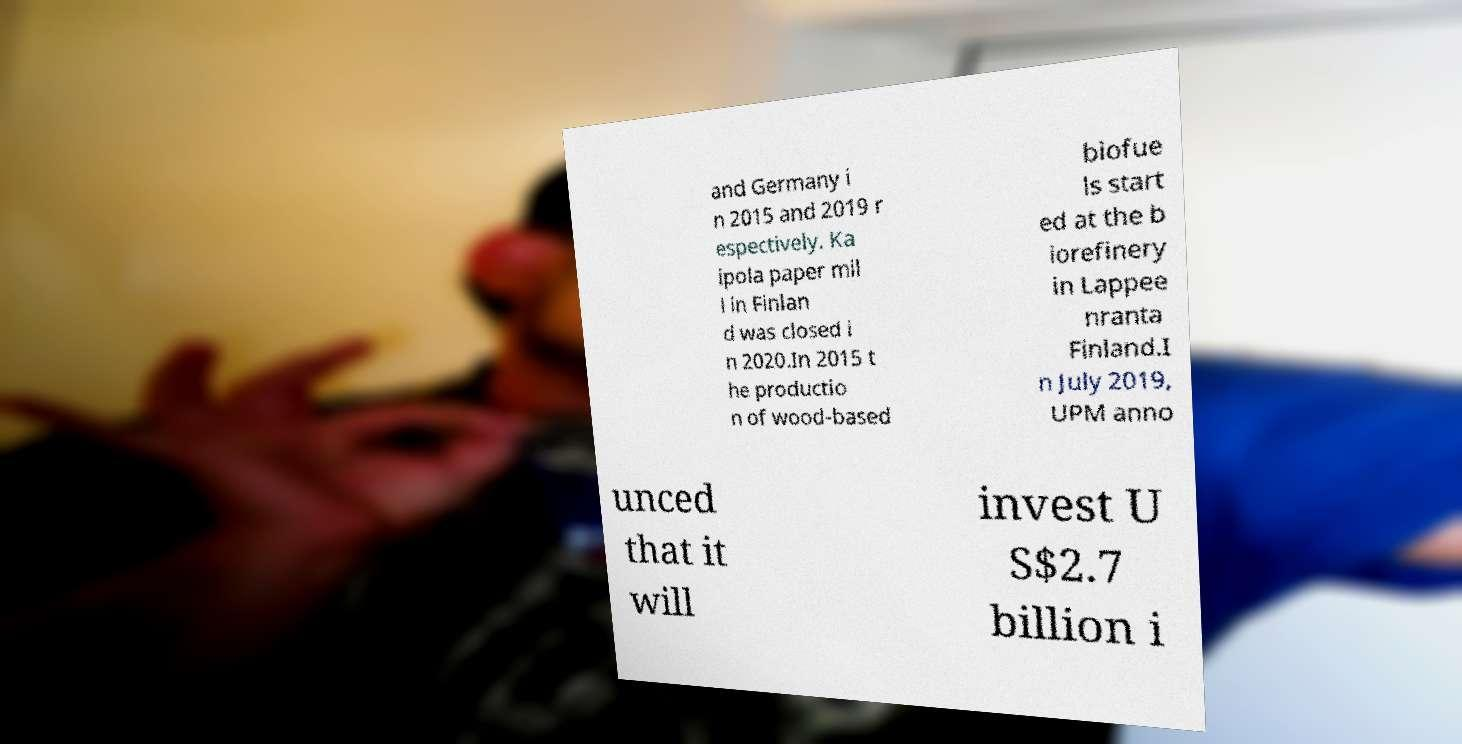Could you assist in decoding the text presented in this image and type it out clearly? and Germany i n 2015 and 2019 r espectively. Ka ipola paper mil l in Finlan d was closed i n 2020.In 2015 t he productio n of wood-based biofue ls start ed at the b iorefinery in Lappee nranta Finland.I n July 2019, UPM anno unced that it will invest U S$2.7 billion i 